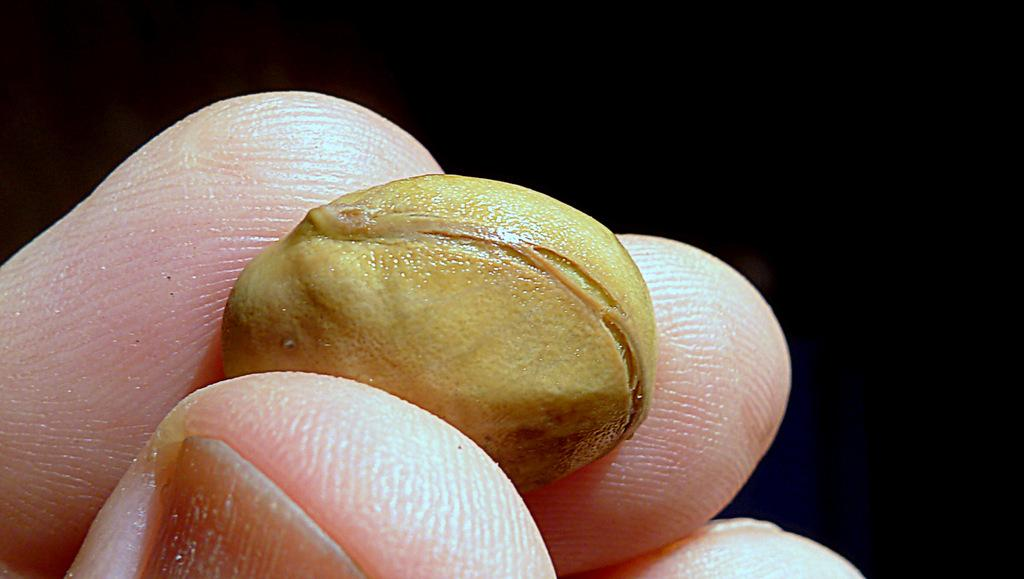What is the person's fingers holding in the image? The person's fingers are holding a small object in the image. What can be observed about the background of the image? The background of the image is dark. What condition are the kittens in at the school in the image? There are no kittens or school present in the image; it only shows a person's fingers holding a small object with a dark background. 